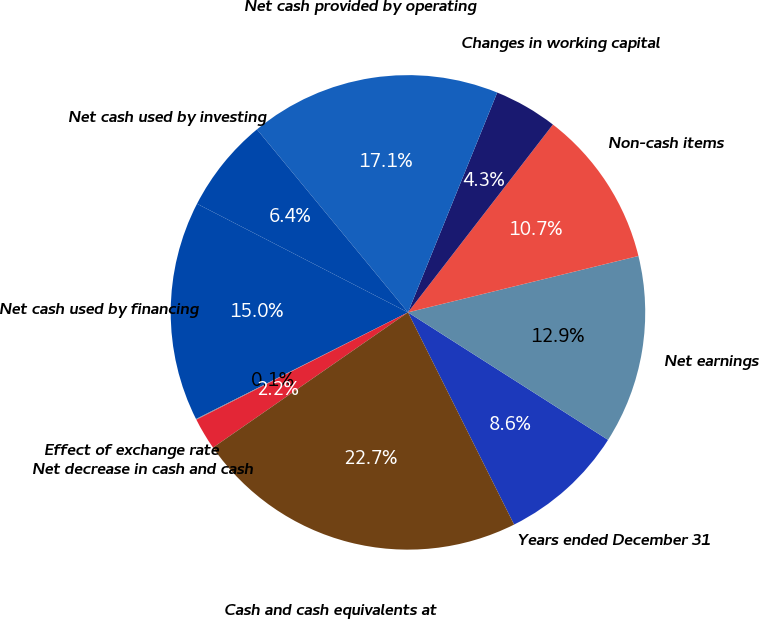Convert chart to OTSL. <chart><loc_0><loc_0><loc_500><loc_500><pie_chart><fcel>Years ended December 31<fcel>Net earnings<fcel>Non-cash items<fcel>Changes in working capital<fcel>Net cash provided by operating<fcel>Net cash used by investing<fcel>Net cash used by financing<fcel>Effect of exchange rate<fcel>Net decrease in cash and cash<fcel>Cash and cash equivalents at<nl><fcel>8.59%<fcel>12.85%<fcel>10.72%<fcel>4.32%<fcel>17.12%<fcel>6.45%<fcel>14.99%<fcel>0.05%<fcel>2.18%<fcel>22.73%<nl></chart> 